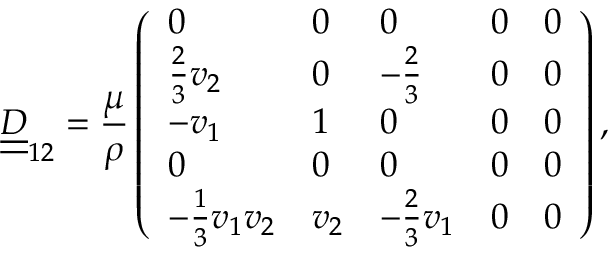<formula> <loc_0><loc_0><loc_500><loc_500>\underline { { \underline { D } } } _ { 1 2 } = \frac { \mu } { \rho } \left ( \begin{array} { l l l l l } { 0 } & { 0 } & { 0 } & { 0 } & { 0 } \\ { \frac { 2 } { 3 } v _ { 2 } } & { 0 } & { - \frac { 2 } { 3 } } & { 0 } & { 0 } \\ { - v _ { 1 } } & { 1 } & { 0 } & { 0 } & { 0 } \\ { 0 } & { 0 } & { 0 } & { 0 } & { 0 } \\ { - \frac { 1 } { 3 } v _ { 1 } v _ { 2 } } & { v _ { 2 } } & { - \frac { 2 } { 3 } v _ { 1 } } & { 0 } & { 0 } \end{array} \right ) ,</formula> 